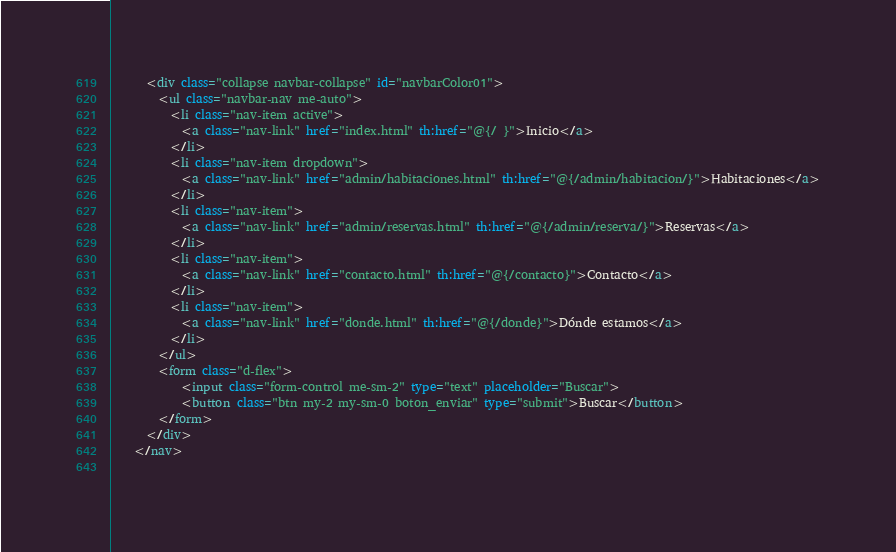Convert code to text. <code><loc_0><loc_0><loc_500><loc_500><_HTML_>
	  <div class="collapse navbar-collapse" id="navbarColor01">
	    <ul class="navbar-nav me-auto">
	      <li class="nav-item active">
	        <a class="nav-link" href="index.html" th:href="@{/ }">Inicio</a>
	      </li>
	      <li class="nav-item dropdown">
	        <a class="nav-link" href="admin/habitaciones.html" th:href="@{/admin/habitacion/}">Habitaciones</a>
	      </li>
	      <li class="nav-item">
	        <a class="nav-link" href="admin/reservas.html" th:href="@{/admin/reserva/}">Reservas</a>
	      </li>
	      <li class="nav-item">
	        <a class="nav-link" href="contacto.html" th:href="@{/contacto}">Contacto</a>
	      </li>
	      <li class="nav-item">
	        <a class="nav-link" href="donde.html" th:href="@{/donde}">Dónde estamos</a>
	      </li>
	    </ul>
	    <form class="d-flex">
	    	<input class="form-control me-sm-2" type="text" placeholder="Buscar">
        	<button class="btn my-2 my-sm-0 boton_enviar" type="submit">Buscar</button>
	    </form>
	  </div>
	</nav>
	</code> 